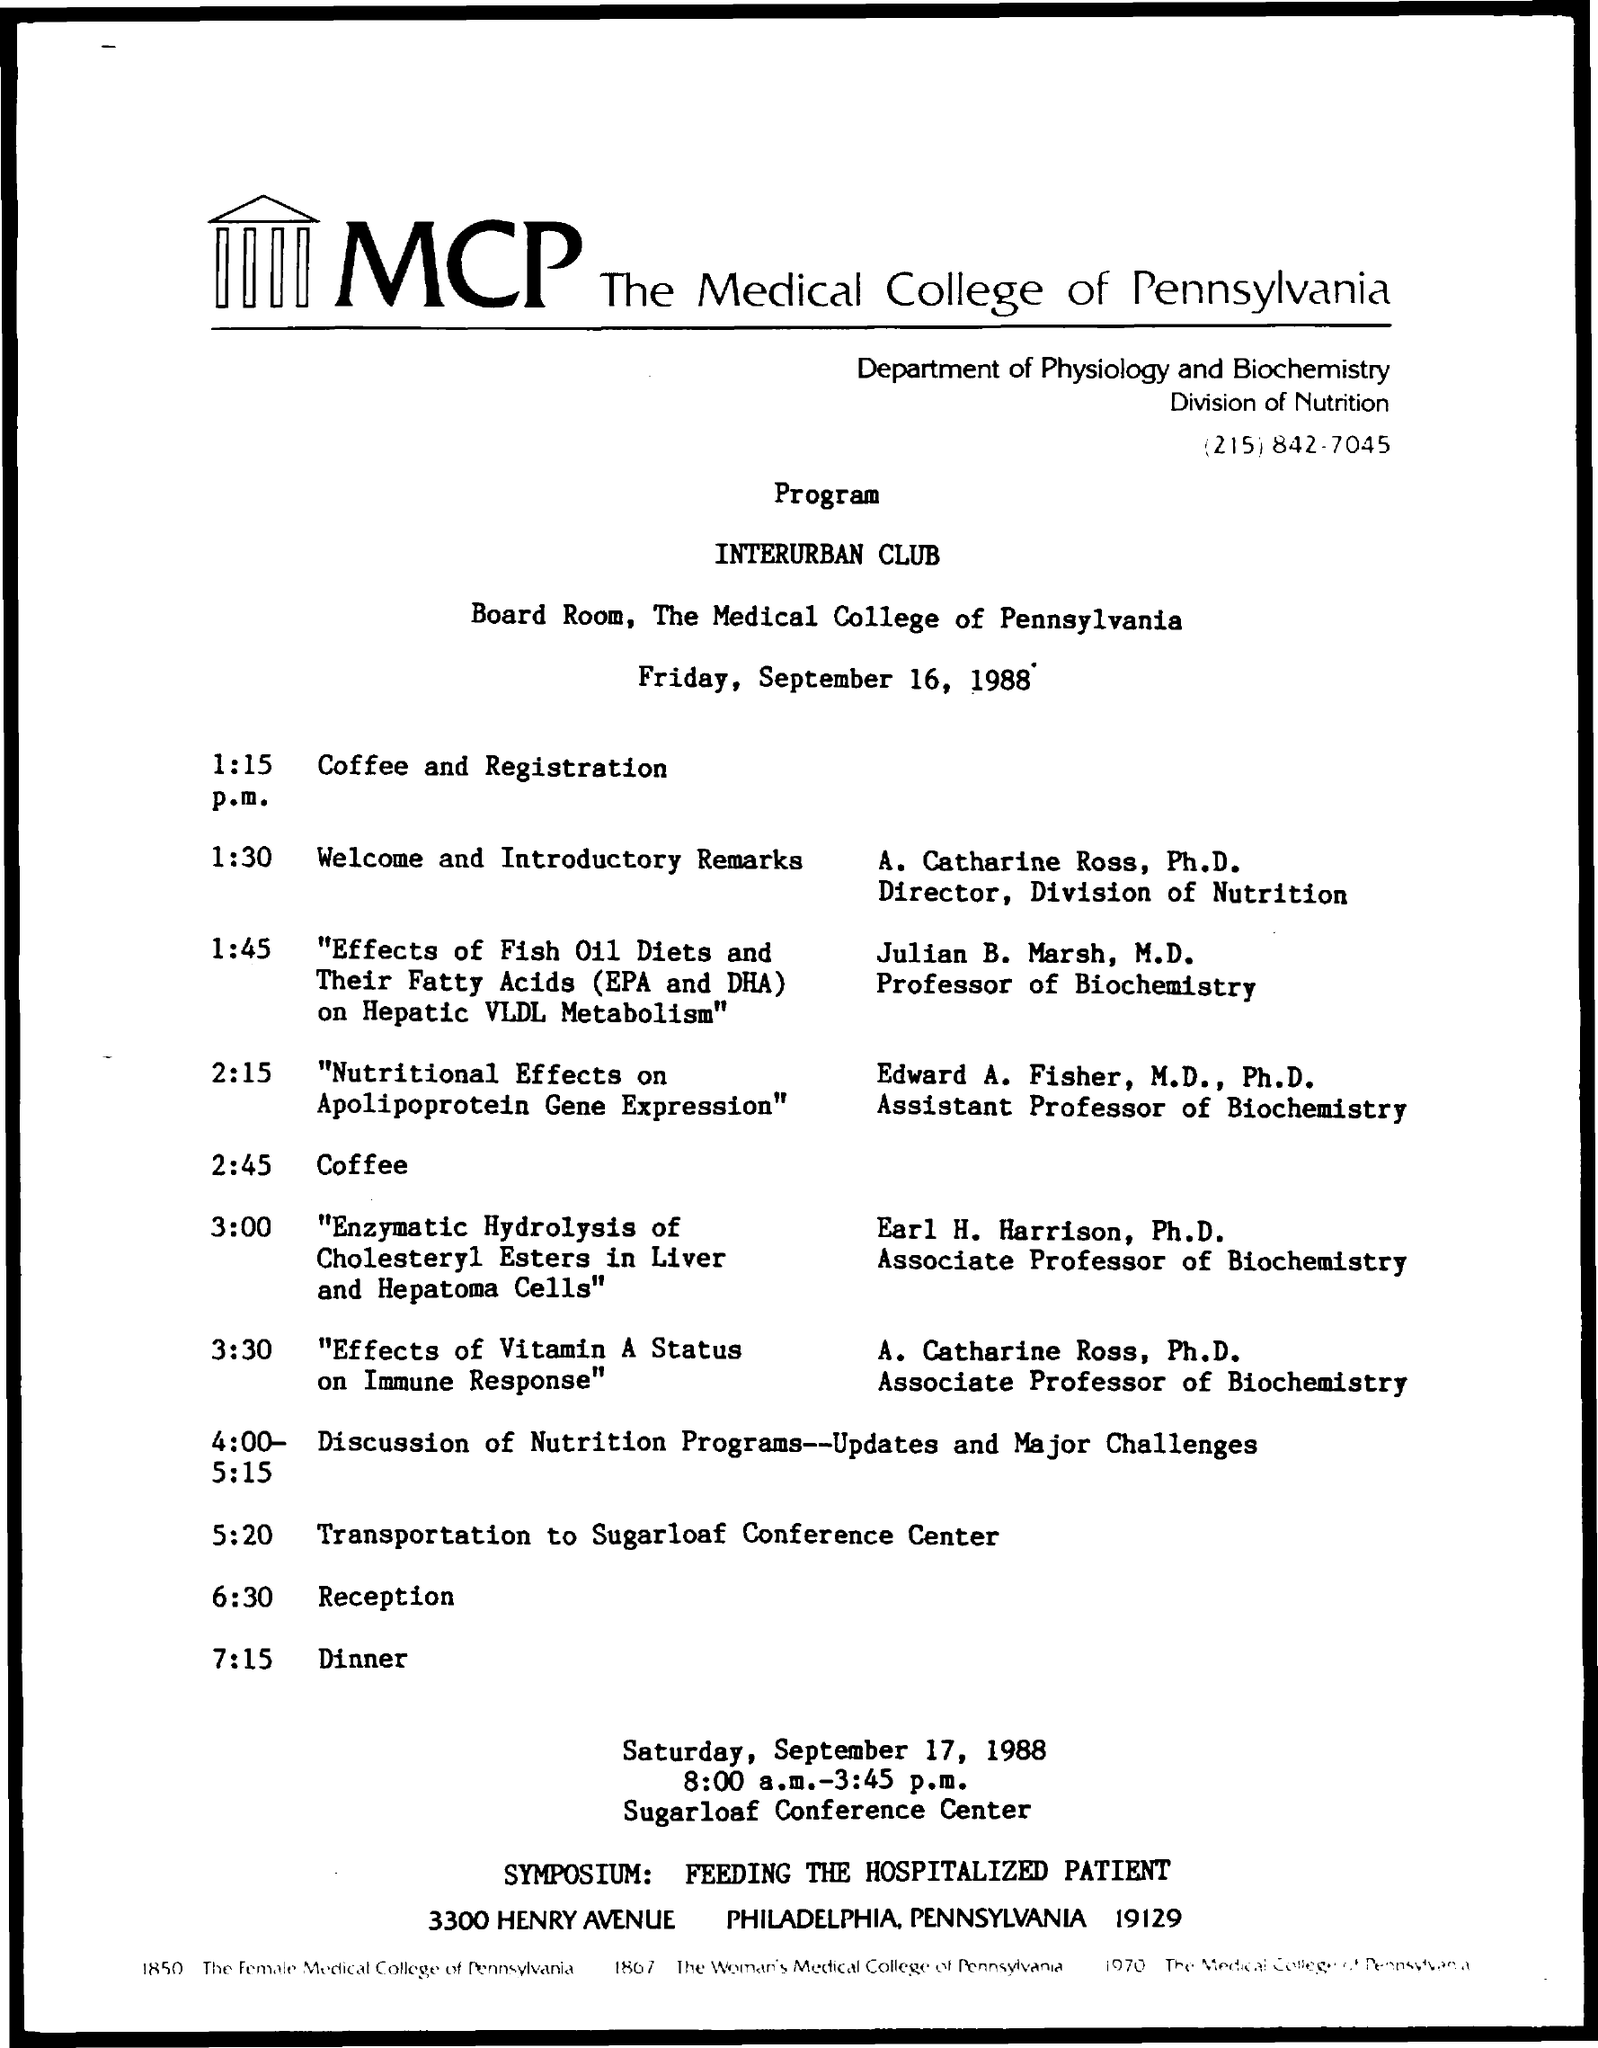Identify some key points in this picture. The schedule at 2:45 p.m. is as follows: coffee. At 1:15 p.m., the schedule includes coffee and registration. At 6:30 p.m., the given schedule is as follows: reception. The date for the given program is scheduled for Friday, September 16, 1988. At 1:30 p.m., the schedule will be as follows: welcome and introductory remarks. 